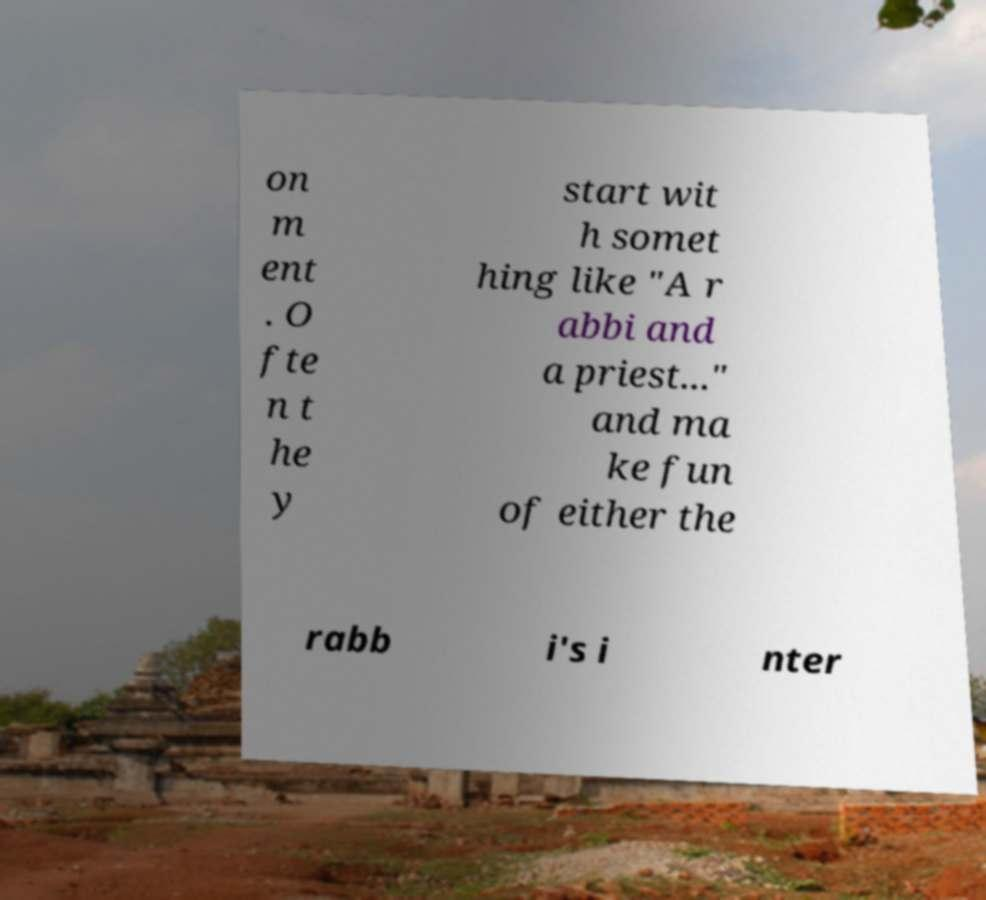Please identify and transcribe the text found in this image. on m ent . O fte n t he y start wit h somet hing like "A r abbi and a priest..." and ma ke fun of either the rabb i's i nter 